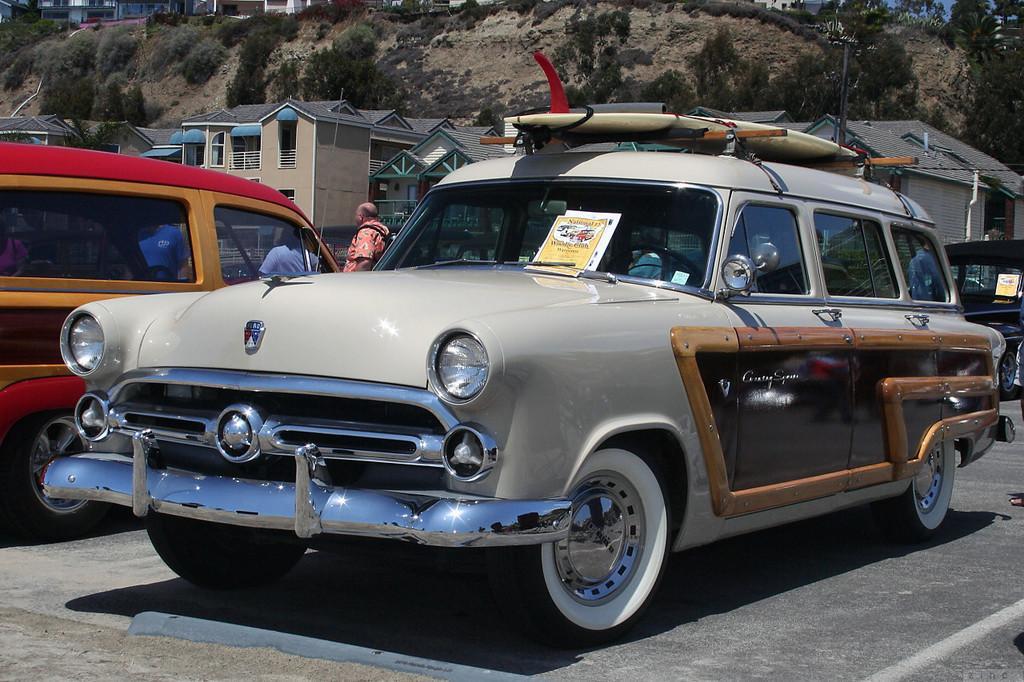Please provide a concise description of this image. This picture is clicked outside. In the center we can see the group of vehicles seems to be parked on the ground and we can see the group of persons. In the background we can see the houses, rocks, plants, grass and we can see the windows of the houses and some other objects. 